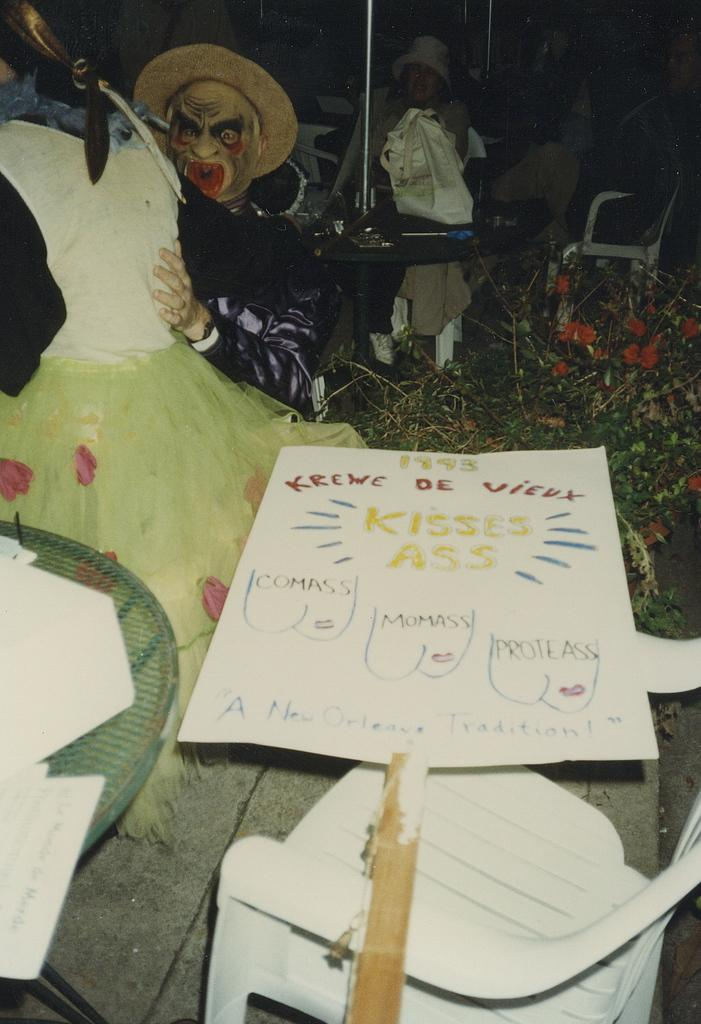<image>
Render a clear and concise summary of the photo. A Krewe de Vieux sign on a stick. 